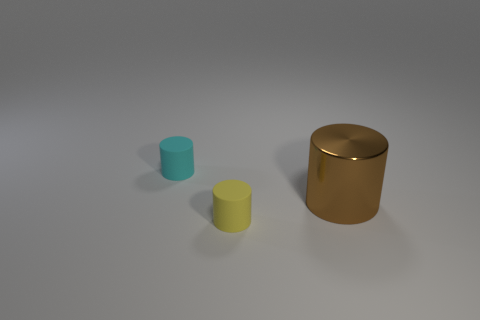What is the shape of the big thing?
Provide a succinct answer. Cylinder. How many cylinders are behind the large metallic object and right of the small cyan matte object?
Give a very brief answer. 0. There is a tiny cyan object that is the same shape as the small yellow matte object; what material is it?
Your answer should be compact. Rubber. Is there anything else that has the same material as the tiny cyan object?
Make the answer very short. Yes. Are there an equal number of metal things that are behind the cyan matte object and small rubber cylinders that are behind the large brown metal object?
Your answer should be very brief. No. Does the yellow cylinder have the same material as the brown cylinder?
Keep it short and to the point. No. How many brown objects are either tiny rubber cylinders or rubber spheres?
Your response must be concise. 0. How many other brown things have the same shape as the brown object?
Provide a succinct answer. 0. What is the yellow cylinder made of?
Offer a very short reply. Rubber. Are there an equal number of large brown metal cylinders on the right side of the small yellow cylinder and large brown cylinders?
Ensure brevity in your answer.  Yes. 